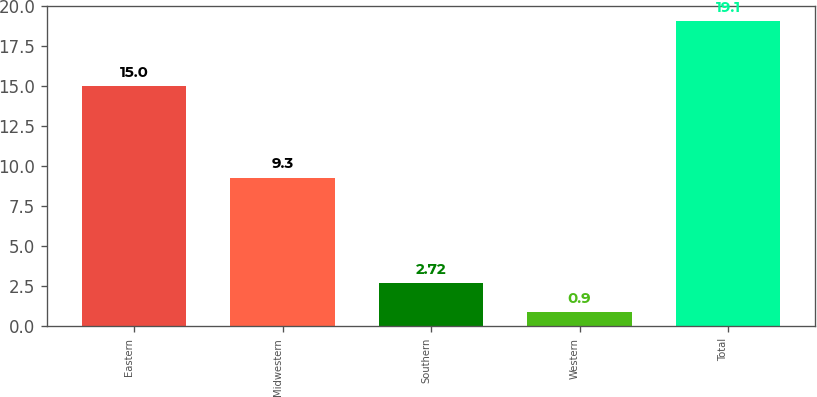<chart> <loc_0><loc_0><loc_500><loc_500><bar_chart><fcel>Eastern<fcel>Midwestern<fcel>Southern<fcel>Western<fcel>Total<nl><fcel>15<fcel>9.3<fcel>2.72<fcel>0.9<fcel>19.1<nl></chart> 